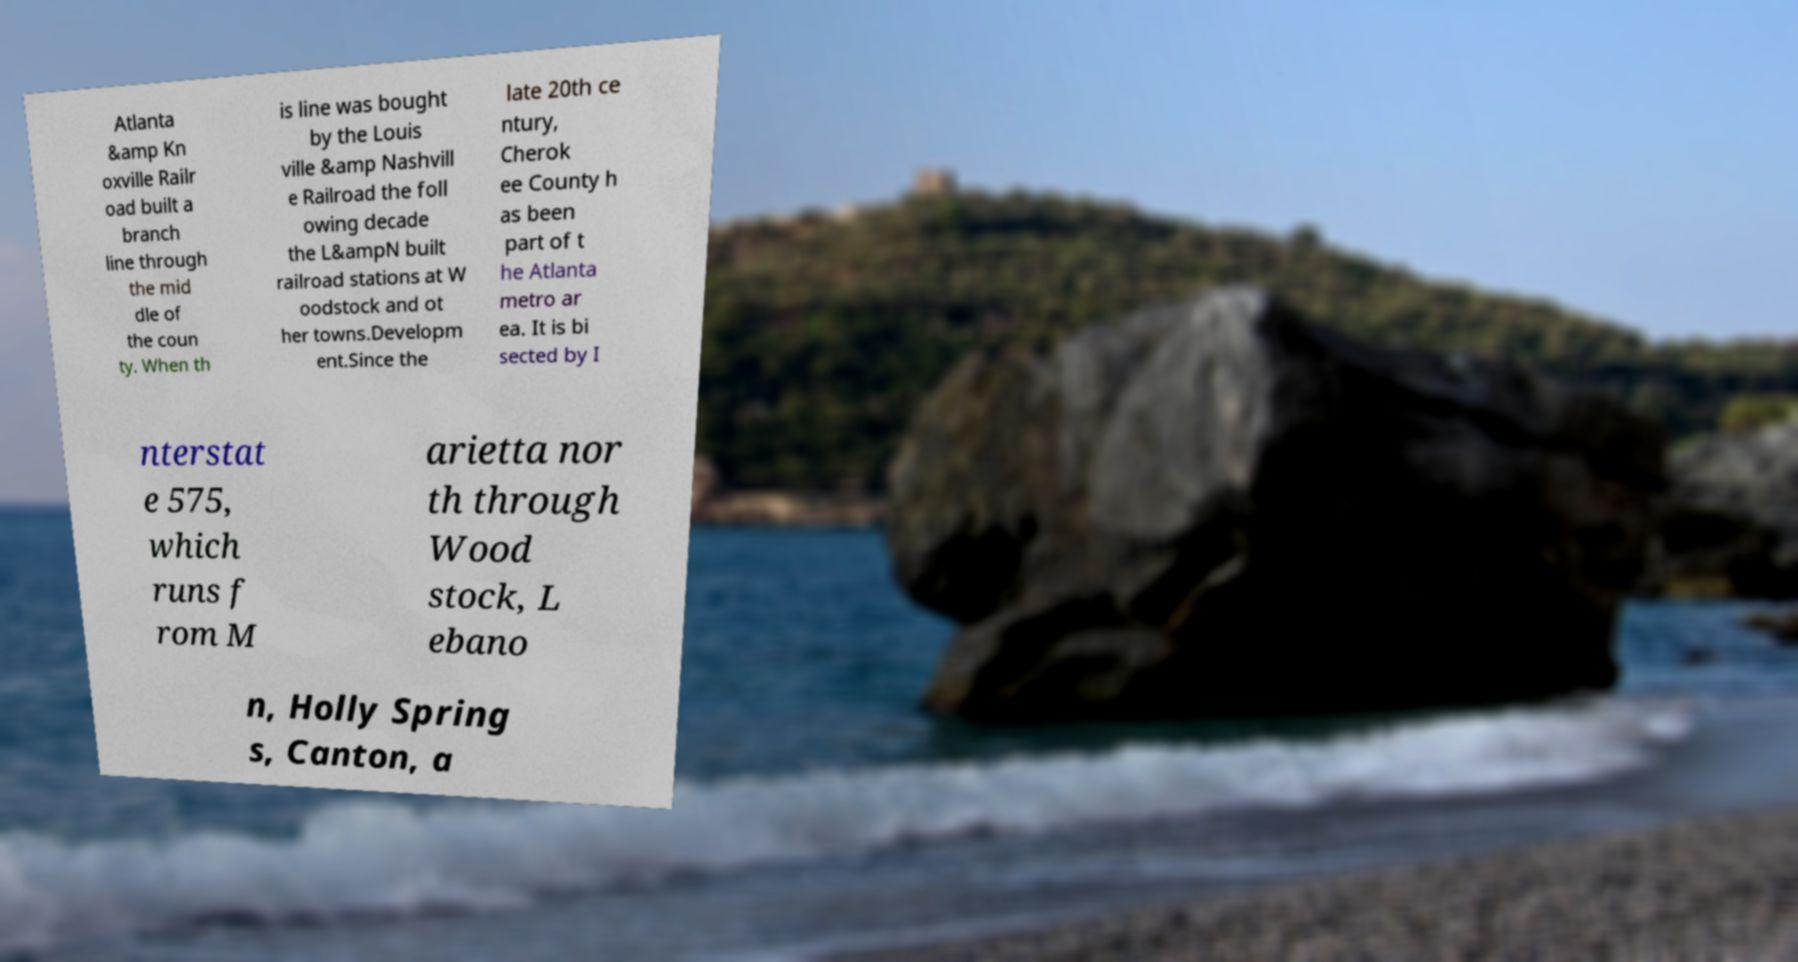Could you assist in decoding the text presented in this image and type it out clearly? Atlanta &amp Kn oxville Railr oad built a branch line through the mid dle of the coun ty. When th is line was bought by the Louis ville &amp Nashvill e Railroad the foll owing decade the L&ampN built railroad stations at W oodstock and ot her towns.Developm ent.Since the late 20th ce ntury, Cherok ee County h as been part of t he Atlanta metro ar ea. It is bi sected by I nterstat e 575, which runs f rom M arietta nor th through Wood stock, L ebano n, Holly Spring s, Canton, a 